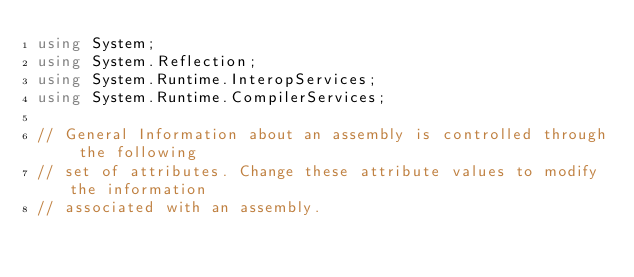Convert code to text. <code><loc_0><loc_0><loc_500><loc_500><_C#_>using System;
using System.Reflection;
using System.Runtime.InteropServices;
using System.Runtime.CompilerServices;

// General Information about an assembly is controlled through the following 
// set of attributes. Change these attribute values to modify the information
// associated with an assembly.</code> 